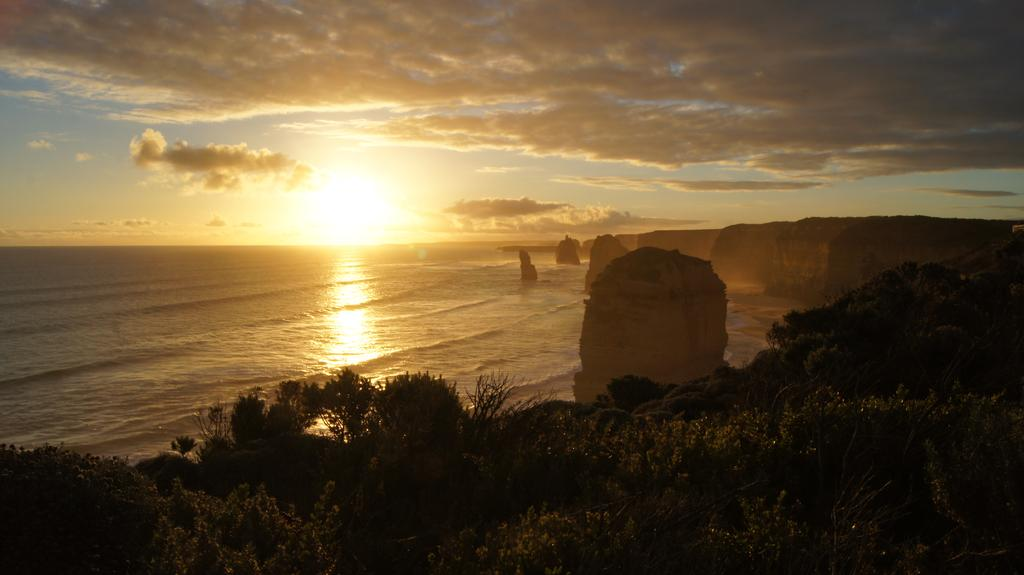What type of living organisms can be seen in the image? Plants can be seen in the image. What else is visible in the image besides the plants? There is water and the sky visible in the image. What part of the natural environment is visible in the image? The sky is visible at the top of the image. What type of quill can be seen in the image? There is no quill present in the image. What level of experience is required to maintain the plants in the image? The image does not provide information about the level of experience required to maintain the plants. 